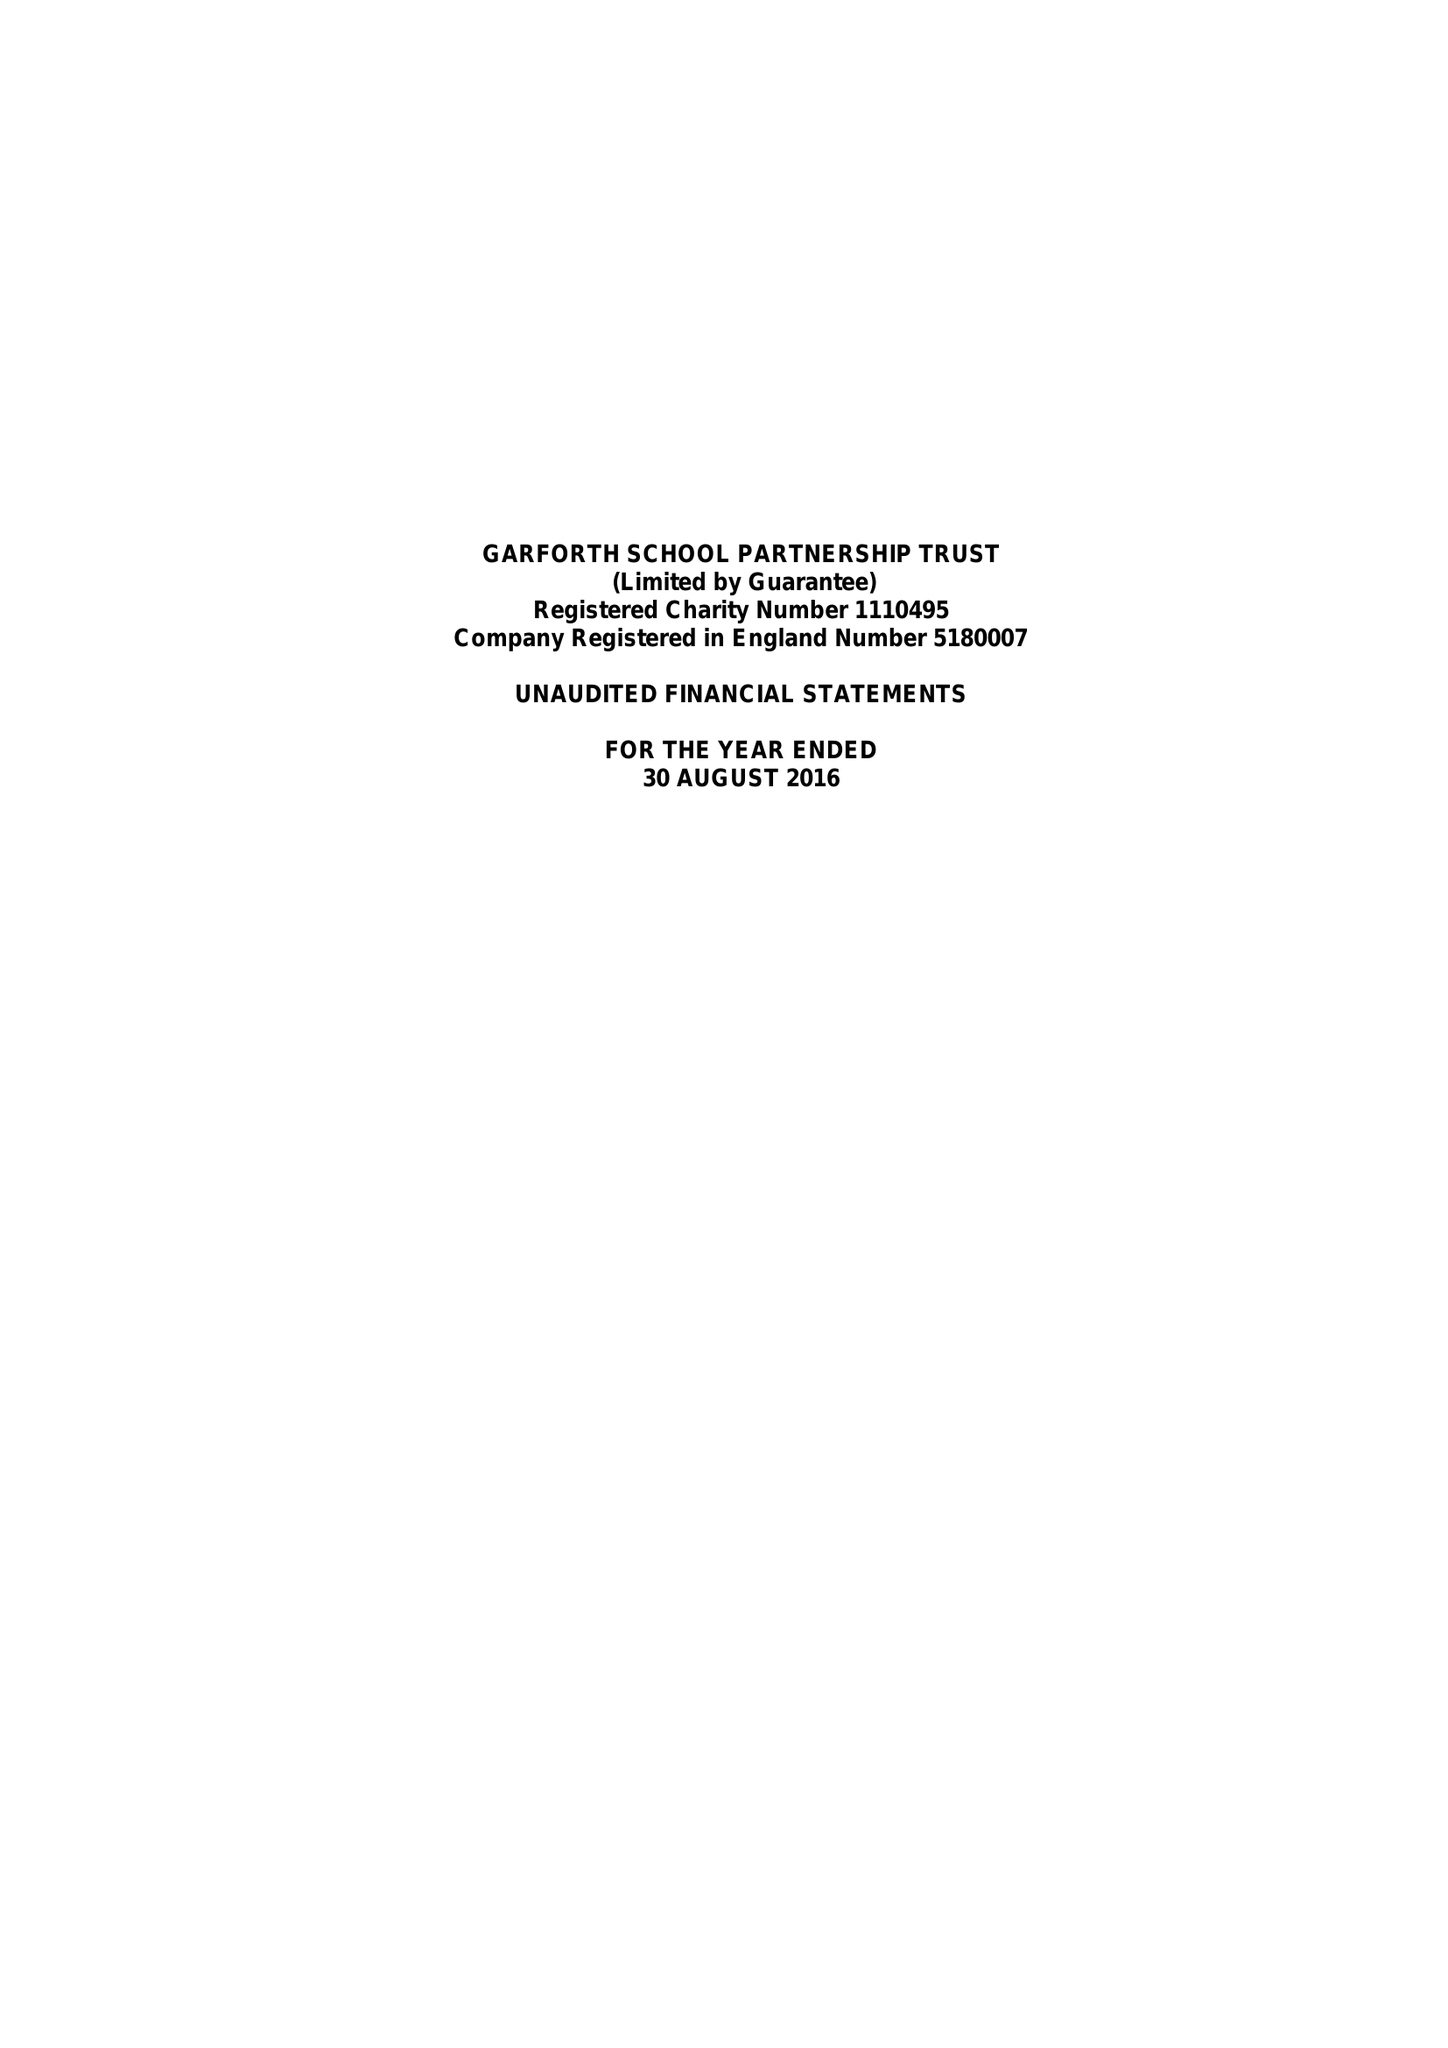What is the value for the address__post_town?
Answer the question using a single word or phrase. LEEDS 